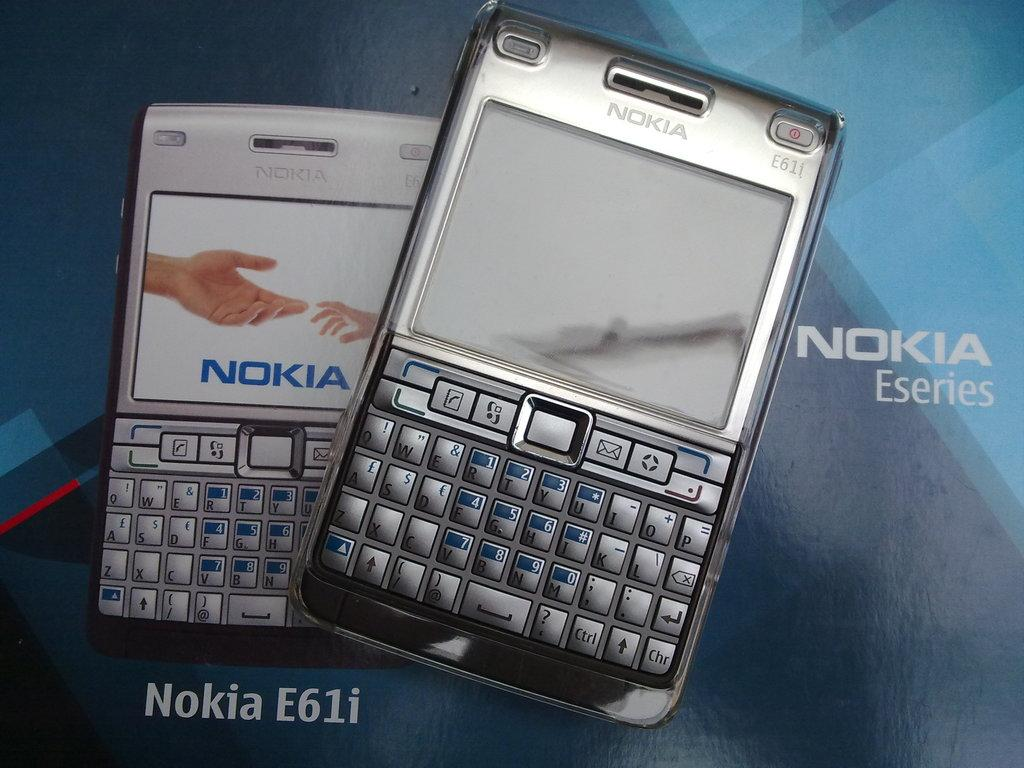<image>
Summarize the visual content of the image. two nokia eseries e61i phones on blue background 